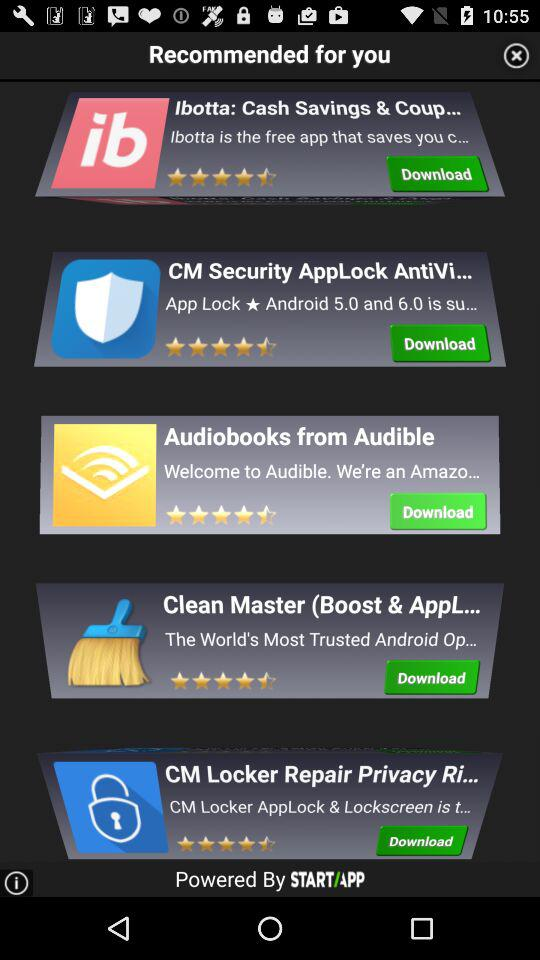Which are the recommended applications for me? The recommended applications are "Ibotta: Cash Savings & Coup...", "CM Security AppLock AntiVi...", "Audiobooks from Audible", "Clean Master (Boost & AppL..." and "CM Locker Repair Privacy Ri...". 